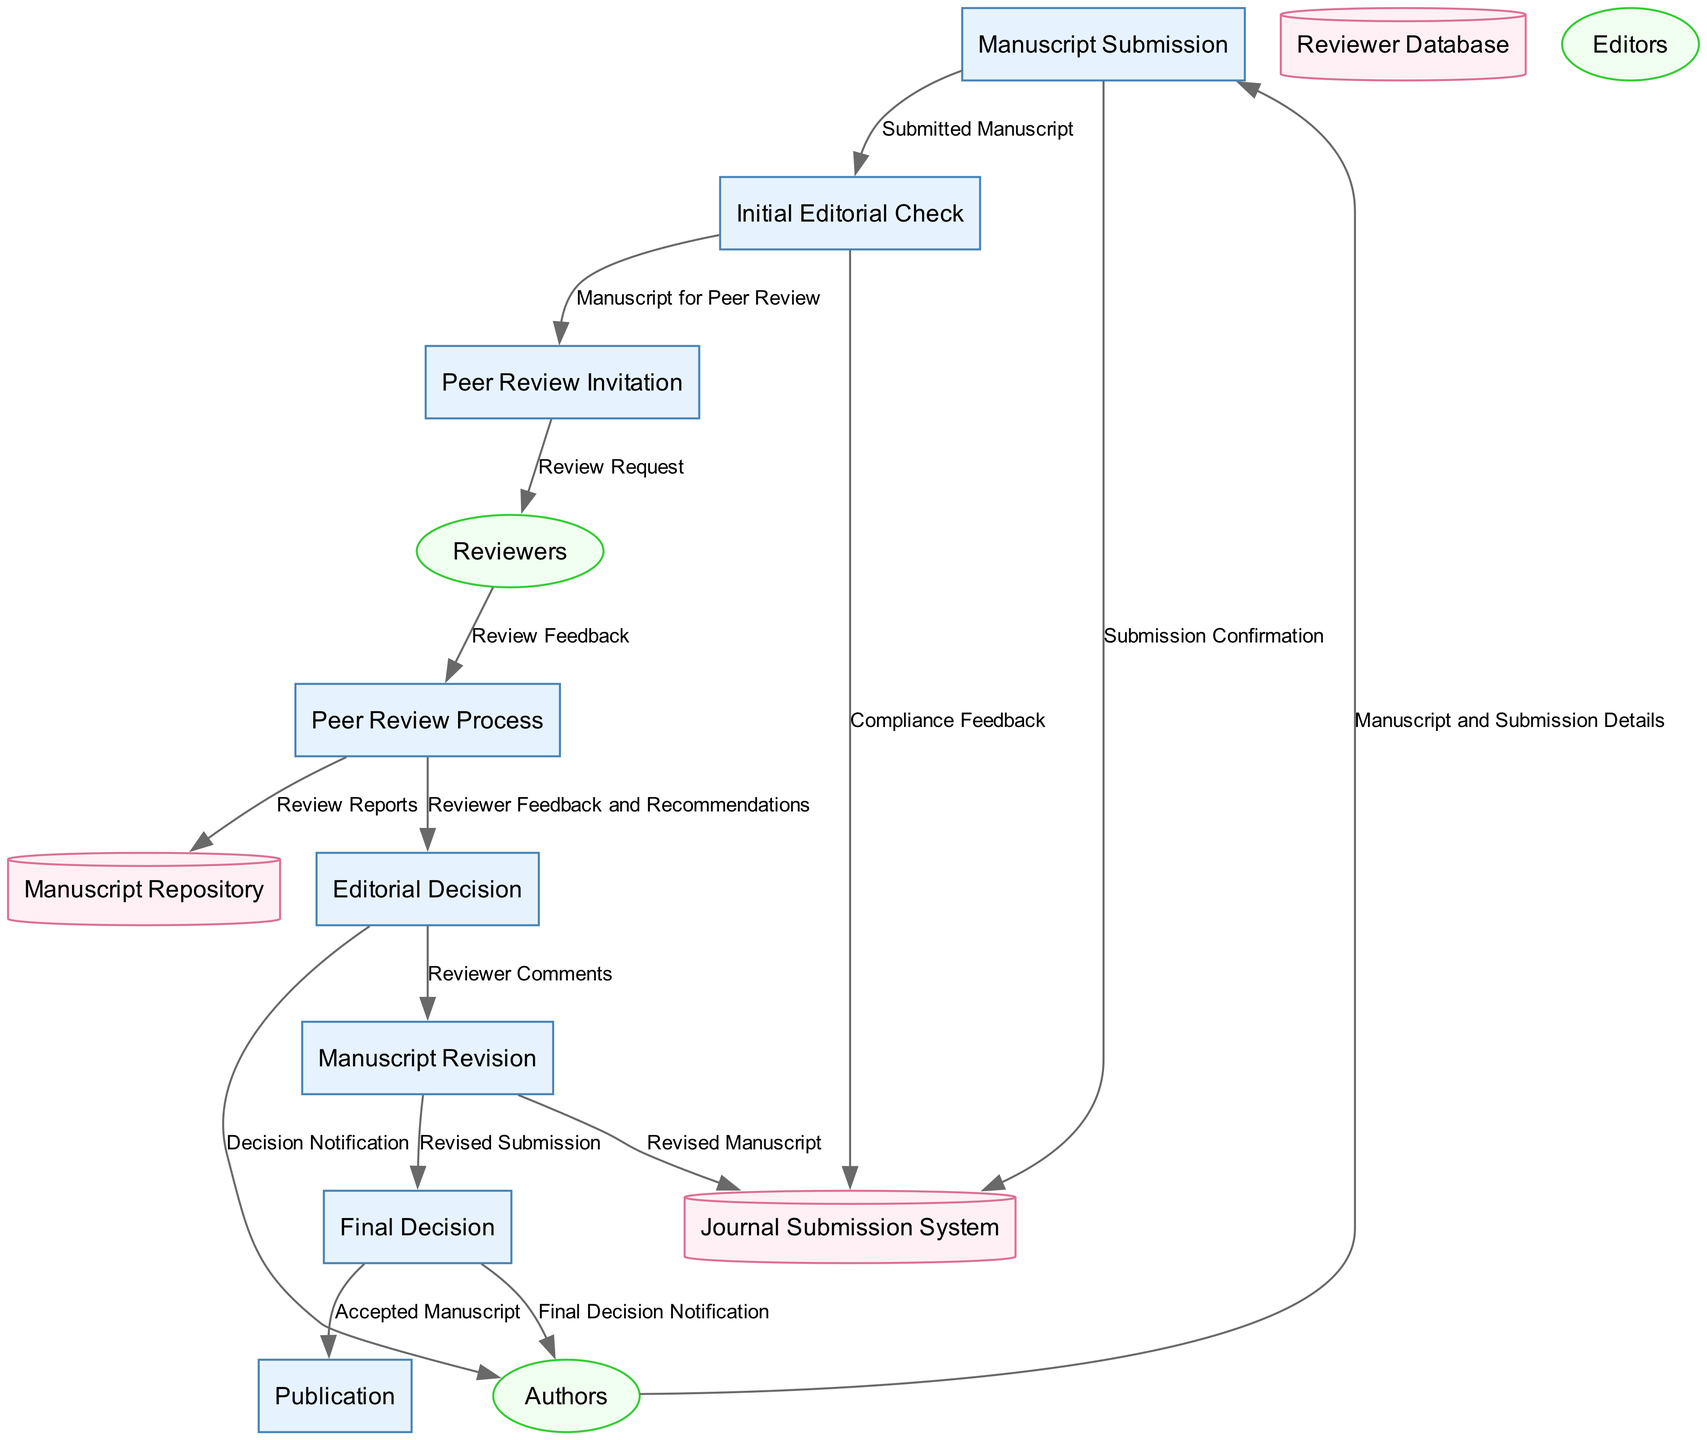What is the first process in the manuscript submission workflow? The first process, as indicated in the diagram, is "Manuscript Submission."
Answer: Manuscript Submission How many external entities are involved in the workflow? The diagram shows three external entities: Authors, Editors, and Reviewers, indicating that there are three.
Answer: 3 Which external entity receives the "Decision Notification"? The "Decision Notification" flows from the "Editorial Decision" process to the "Authors," meaning that the Authors receive this notification.
Answer: Authors What is the last step in the process before publication? The last step before publication is the "Final Decision," as indicated by its position in the diagram, where it leads to the "Publication" process.
Answer: Final Decision How many data flows are present in the diagram? By counting each data flow shown between the nodes, we find there are 14 data flows in total.
Answer: 14 Which process is responsible for revising the manuscript? The "Manuscript Revision" process is designated for this task, as shown in the diagram following the "Editorial Decision."
Answer: Manuscript Revision What type of data store is shown in the diagram? The data stores are represented as cylinders in the diagram; one of the data stores is the "Journal Submission System."
Answer: Journal Submission System What type of feedback do reviewers provide during the peer review process? Reviewers provide "Review Feedback," as indicated by the data flow from the "Reviewers" to the "Peer Review Process."
Answer: Review Feedback Which process directly leads to the "Final Decision"? The "Manuscript Revision" process feeds into the "Final Decision," showing that revisions lead directly to this outcome.
Answer: Manuscript Revision 